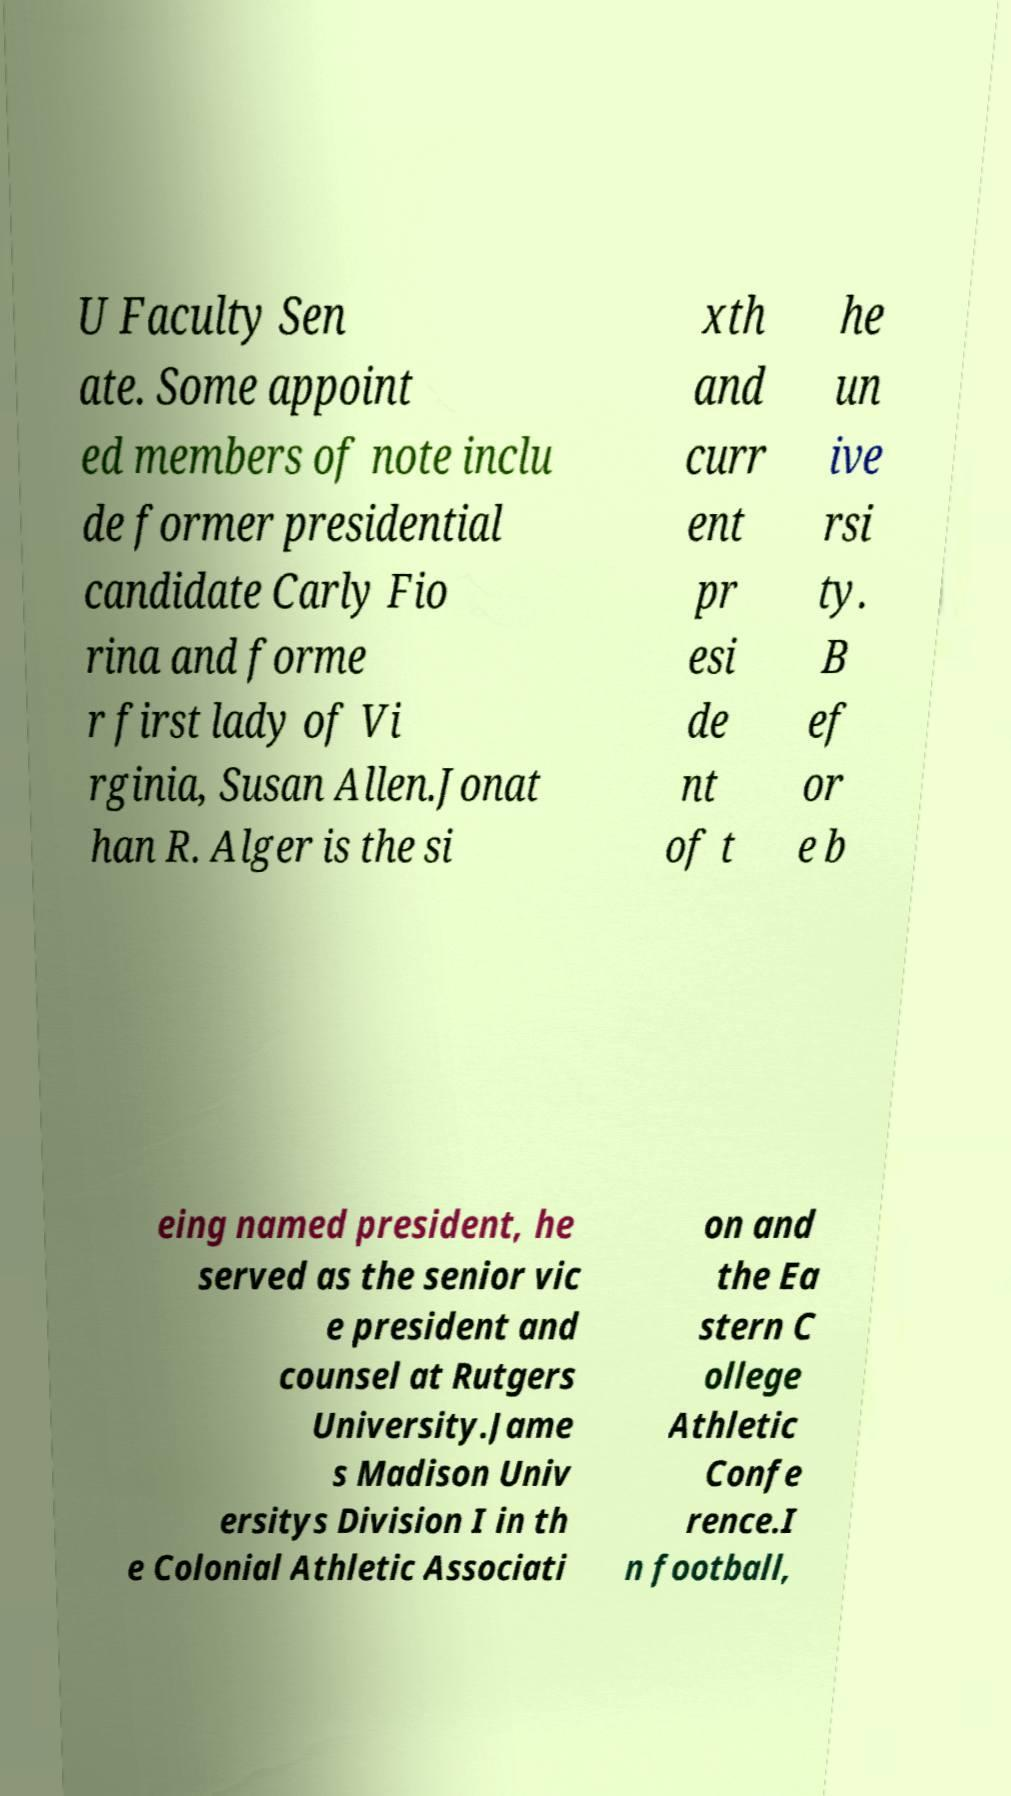For documentation purposes, I need the text within this image transcribed. Could you provide that? U Faculty Sen ate. Some appoint ed members of note inclu de former presidential candidate Carly Fio rina and forme r first lady of Vi rginia, Susan Allen.Jonat han R. Alger is the si xth and curr ent pr esi de nt of t he un ive rsi ty. B ef or e b eing named president, he served as the senior vic e president and counsel at Rutgers University.Jame s Madison Univ ersitys Division I in th e Colonial Athletic Associati on and the Ea stern C ollege Athletic Confe rence.I n football, 